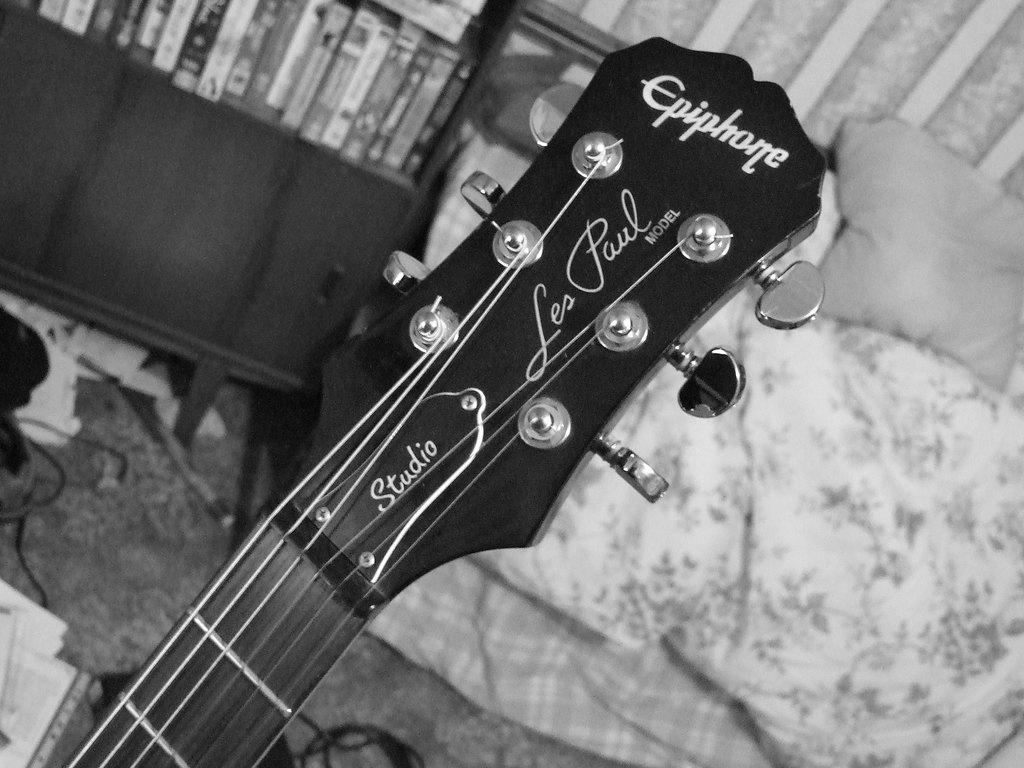Describe this image in one or two sentences. Black and white picture. This is guitar head with tuners. This rack is filled with books. This is a couch with pillow. On floor there is a cable. 